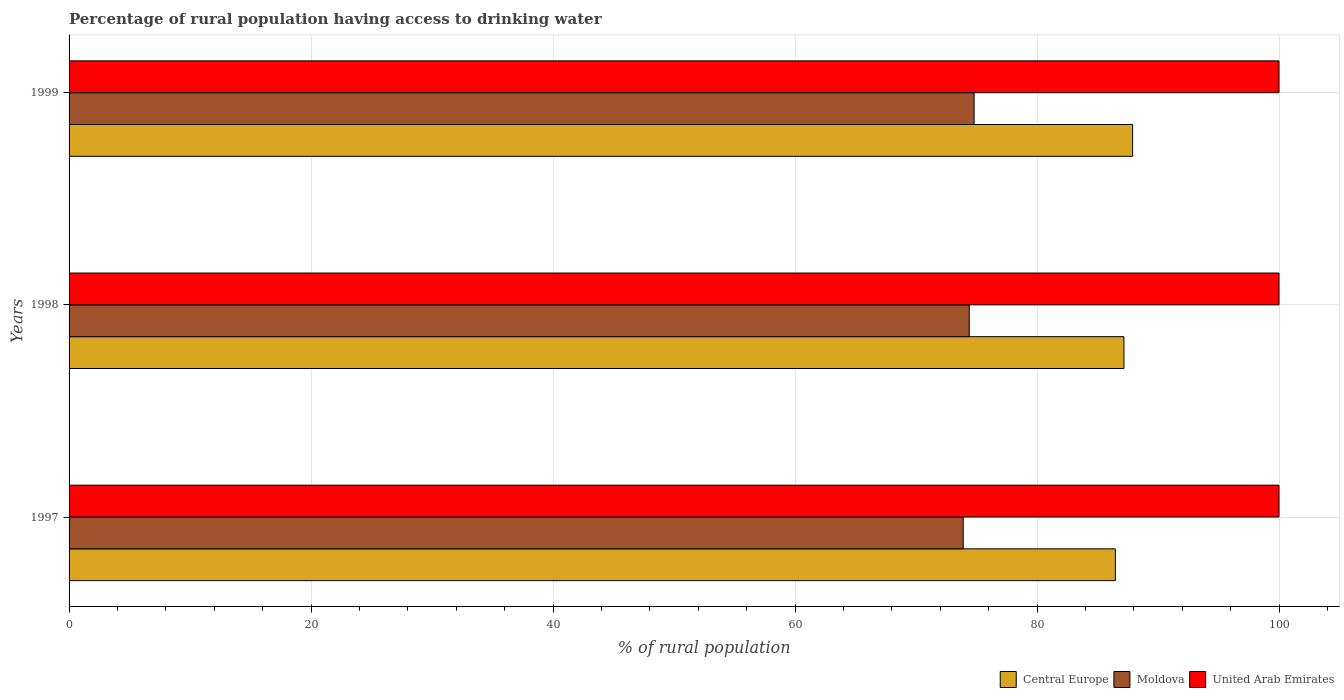How many different coloured bars are there?
Your response must be concise. 3. How many groups of bars are there?
Make the answer very short. 3. Are the number of bars per tick equal to the number of legend labels?
Provide a succinct answer. Yes. How many bars are there on the 2nd tick from the top?
Keep it short and to the point. 3. What is the percentage of rural population having access to drinking water in Central Europe in 1998?
Make the answer very short. 87.19. Across all years, what is the maximum percentage of rural population having access to drinking water in Central Europe?
Keep it short and to the point. 87.9. Across all years, what is the minimum percentage of rural population having access to drinking water in United Arab Emirates?
Provide a succinct answer. 100. In which year was the percentage of rural population having access to drinking water in Moldova maximum?
Ensure brevity in your answer.  1999. In which year was the percentage of rural population having access to drinking water in Moldova minimum?
Ensure brevity in your answer.  1997. What is the total percentage of rural population having access to drinking water in United Arab Emirates in the graph?
Ensure brevity in your answer.  300. What is the difference between the percentage of rural population having access to drinking water in Central Europe in 1998 and that in 1999?
Provide a succinct answer. -0.72. What is the difference between the percentage of rural population having access to drinking water in United Arab Emirates in 1998 and the percentage of rural population having access to drinking water in Moldova in 1999?
Your response must be concise. 25.2. What is the average percentage of rural population having access to drinking water in Moldova per year?
Keep it short and to the point. 74.37. In the year 1998, what is the difference between the percentage of rural population having access to drinking water in Central Europe and percentage of rural population having access to drinking water in Moldova?
Your answer should be compact. 12.79. What is the difference between the highest and the lowest percentage of rural population having access to drinking water in United Arab Emirates?
Your answer should be very brief. 0. Is the sum of the percentage of rural population having access to drinking water in Moldova in 1998 and 1999 greater than the maximum percentage of rural population having access to drinking water in United Arab Emirates across all years?
Offer a very short reply. Yes. What does the 3rd bar from the top in 1999 represents?
Offer a terse response. Central Europe. What does the 3rd bar from the bottom in 1997 represents?
Your answer should be very brief. United Arab Emirates. How many bars are there?
Keep it short and to the point. 9. How many years are there in the graph?
Offer a very short reply. 3. What is the difference between two consecutive major ticks on the X-axis?
Offer a terse response. 20. Does the graph contain any zero values?
Keep it short and to the point. No. Where does the legend appear in the graph?
Provide a succinct answer. Bottom right. How many legend labels are there?
Your response must be concise. 3. What is the title of the graph?
Keep it short and to the point. Percentage of rural population having access to drinking water. What is the label or title of the X-axis?
Keep it short and to the point. % of rural population. What is the label or title of the Y-axis?
Offer a very short reply. Years. What is the % of rural population of Central Europe in 1997?
Ensure brevity in your answer.  86.48. What is the % of rural population of Moldova in 1997?
Your answer should be compact. 73.9. What is the % of rural population of United Arab Emirates in 1997?
Provide a succinct answer. 100. What is the % of rural population of Central Europe in 1998?
Your response must be concise. 87.19. What is the % of rural population in Moldova in 1998?
Provide a short and direct response. 74.4. What is the % of rural population in Central Europe in 1999?
Offer a terse response. 87.9. What is the % of rural population of Moldova in 1999?
Keep it short and to the point. 74.8. What is the % of rural population of United Arab Emirates in 1999?
Your answer should be compact. 100. Across all years, what is the maximum % of rural population of Central Europe?
Offer a very short reply. 87.9. Across all years, what is the maximum % of rural population of Moldova?
Give a very brief answer. 74.8. Across all years, what is the minimum % of rural population of Central Europe?
Your answer should be very brief. 86.48. Across all years, what is the minimum % of rural population of Moldova?
Offer a very short reply. 73.9. What is the total % of rural population of Central Europe in the graph?
Your answer should be very brief. 261.56. What is the total % of rural population of Moldova in the graph?
Ensure brevity in your answer.  223.1. What is the total % of rural population in United Arab Emirates in the graph?
Make the answer very short. 300. What is the difference between the % of rural population of Central Europe in 1997 and that in 1998?
Offer a very short reply. -0.71. What is the difference between the % of rural population of Moldova in 1997 and that in 1998?
Your answer should be very brief. -0.5. What is the difference between the % of rural population of Central Europe in 1997 and that in 1999?
Your answer should be compact. -1.43. What is the difference between the % of rural population in United Arab Emirates in 1997 and that in 1999?
Give a very brief answer. 0. What is the difference between the % of rural population of Central Europe in 1998 and that in 1999?
Offer a very short reply. -0.72. What is the difference between the % of rural population in Moldova in 1998 and that in 1999?
Provide a short and direct response. -0.4. What is the difference between the % of rural population in United Arab Emirates in 1998 and that in 1999?
Offer a terse response. 0. What is the difference between the % of rural population in Central Europe in 1997 and the % of rural population in Moldova in 1998?
Your answer should be very brief. 12.08. What is the difference between the % of rural population in Central Europe in 1997 and the % of rural population in United Arab Emirates in 1998?
Make the answer very short. -13.52. What is the difference between the % of rural population in Moldova in 1997 and the % of rural population in United Arab Emirates in 1998?
Ensure brevity in your answer.  -26.1. What is the difference between the % of rural population of Central Europe in 1997 and the % of rural population of Moldova in 1999?
Your response must be concise. 11.68. What is the difference between the % of rural population in Central Europe in 1997 and the % of rural population in United Arab Emirates in 1999?
Your answer should be very brief. -13.52. What is the difference between the % of rural population of Moldova in 1997 and the % of rural population of United Arab Emirates in 1999?
Your answer should be very brief. -26.1. What is the difference between the % of rural population of Central Europe in 1998 and the % of rural population of Moldova in 1999?
Provide a short and direct response. 12.39. What is the difference between the % of rural population in Central Europe in 1998 and the % of rural population in United Arab Emirates in 1999?
Provide a short and direct response. -12.81. What is the difference between the % of rural population in Moldova in 1998 and the % of rural population in United Arab Emirates in 1999?
Keep it short and to the point. -25.6. What is the average % of rural population of Central Europe per year?
Give a very brief answer. 87.19. What is the average % of rural population of Moldova per year?
Make the answer very short. 74.37. What is the average % of rural population in United Arab Emirates per year?
Give a very brief answer. 100. In the year 1997, what is the difference between the % of rural population of Central Europe and % of rural population of Moldova?
Offer a terse response. 12.58. In the year 1997, what is the difference between the % of rural population in Central Europe and % of rural population in United Arab Emirates?
Give a very brief answer. -13.52. In the year 1997, what is the difference between the % of rural population in Moldova and % of rural population in United Arab Emirates?
Your answer should be very brief. -26.1. In the year 1998, what is the difference between the % of rural population of Central Europe and % of rural population of Moldova?
Ensure brevity in your answer.  12.79. In the year 1998, what is the difference between the % of rural population of Central Europe and % of rural population of United Arab Emirates?
Offer a very short reply. -12.81. In the year 1998, what is the difference between the % of rural population in Moldova and % of rural population in United Arab Emirates?
Give a very brief answer. -25.6. In the year 1999, what is the difference between the % of rural population in Central Europe and % of rural population in Moldova?
Give a very brief answer. 13.1. In the year 1999, what is the difference between the % of rural population in Central Europe and % of rural population in United Arab Emirates?
Your response must be concise. -12.1. In the year 1999, what is the difference between the % of rural population of Moldova and % of rural population of United Arab Emirates?
Your answer should be very brief. -25.2. What is the ratio of the % of rural population of Central Europe in 1997 to that in 1998?
Provide a short and direct response. 0.99. What is the ratio of the % of rural population of Central Europe in 1997 to that in 1999?
Your answer should be compact. 0.98. What is the ratio of the % of rural population in Moldova in 1997 to that in 1999?
Offer a very short reply. 0.99. What is the ratio of the % of rural population of Moldova in 1998 to that in 1999?
Give a very brief answer. 0.99. What is the ratio of the % of rural population of United Arab Emirates in 1998 to that in 1999?
Offer a terse response. 1. What is the difference between the highest and the second highest % of rural population in Central Europe?
Make the answer very short. 0.72. What is the difference between the highest and the second highest % of rural population in United Arab Emirates?
Offer a very short reply. 0. What is the difference between the highest and the lowest % of rural population in Central Europe?
Offer a very short reply. 1.43. What is the difference between the highest and the lowest % of rural population in Moldova?
Ensure brevity in your answer.  0.9. What is the difference between the highest and the lowest % of rural population of United Arab Emirates?
Your answer should be compact. 0. 